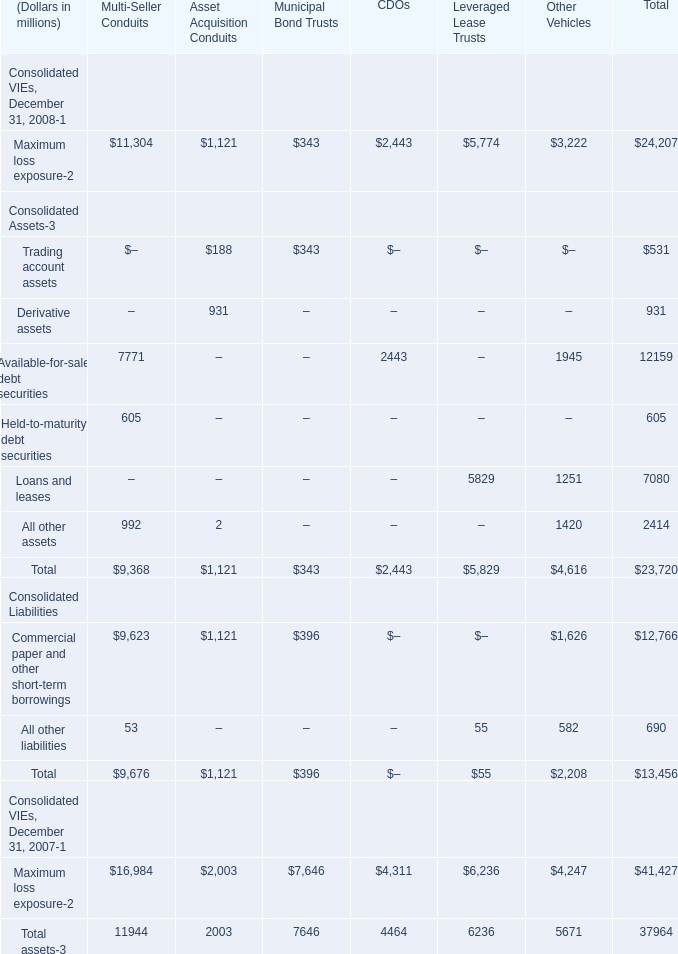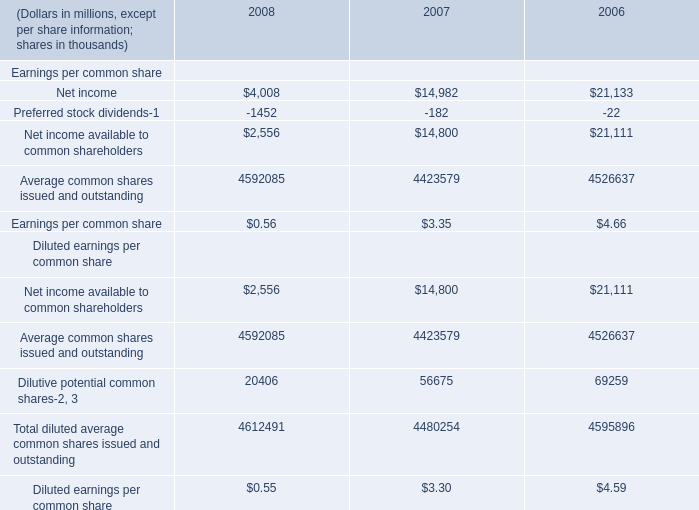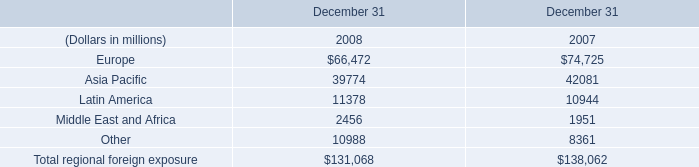What is the ratioof Available-for-sale debt securities to the total in 2008? (in %) 
Computations: (7771 / 12159)
Answer: 0.63912. 